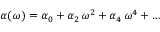Convert formula to latex. <formula><loc_0><loc_0><loc_500><loc_500>\begin{array} { r } { \alpha ( \omega ) = \alpha _ { 0 } + \alpha _ { 2 } \, \omega ^ { 2 } + \alpha _ { 4 } \, \omega ^ { 4 } + \dots } \end{array}</formula> 